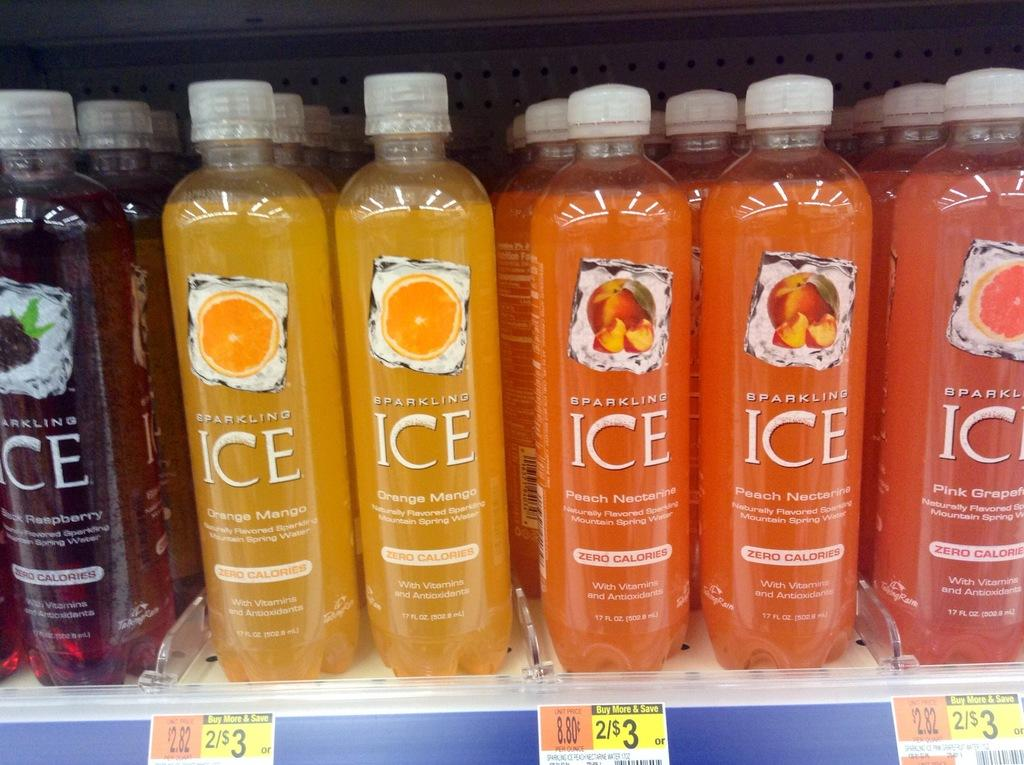<image>
Create a compact narrative representing the image presented. Sparkling Ice Beverages in different flavors on a store shelf that is priced 2 for 3 dollars. 